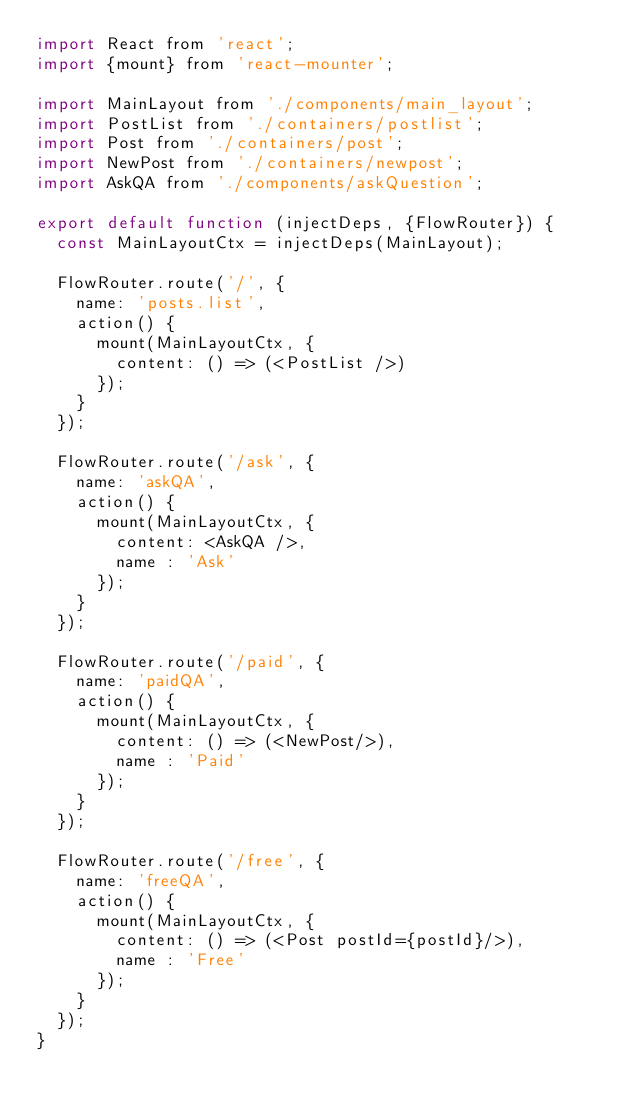<code> <loc_0><loc_0><loc_500><loc_500><_JavaScript_>import React from 'react';
import {mount} from 'react-mounter';

import MainLayout from './components/main_layout';
import PostList from './containers/postlist';
import Post from './containers/post';
import NewPost from './containers/newpost';
import AskQA from './components/askQuestion';

export default function (injectDeps, {FlowRouter}) {
  const MainLayoutCtx = injectDeps(MainLayout);

  FlowRouter.route('/', {
    name: 'posts.list',
    action() {
      mount(MainLayoutCtx, {
        content: () => (<PostList />)
      });
    }
  });

  FlowRouter.route('/ask', {
    name: 'askQA',
    action() {
      mount(MainLayoutCtx, {
        content: <AskQA />,
        name : 'Ask'
      });
    }
  });

  FlowRouter.route('/paid', {
    name: 'paidQA',
    action() {
      mount(MainLayoutCtx, {
        content: () => (<NewPost/>),
        name : 'Paid'
      });
    }
  });

  FlowRouter.route('/free', {
    name: 'freeQA',
    action() {
      mount(MainLayoutCtx, {
        content: () => (<Post postId={postId}/>),
        name : 'Free'
      });
    }
  });
}
</code> 